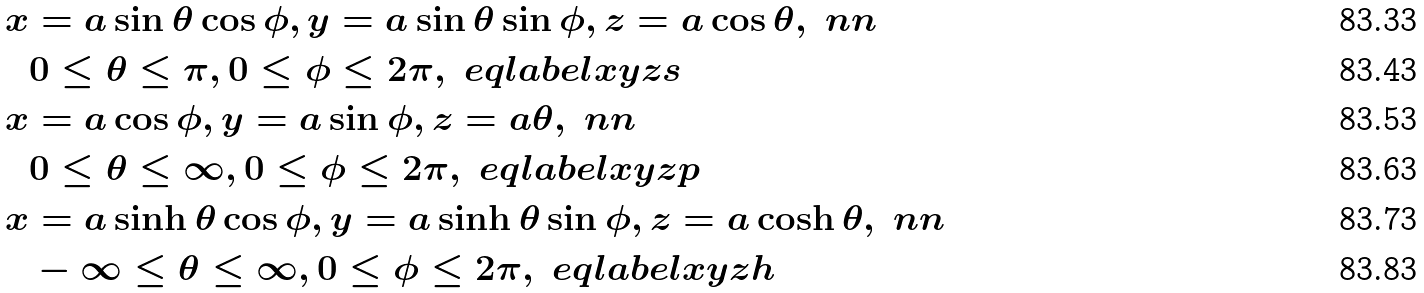<formula> <loc_0><loc_0><loc_500><loc_500>x & = a \sin \theta \cos \phi , y = a \sin \theta \sin \phi , z = a \cos \theta , \ n n \\ & 0 \leq \theta \leq \pi , 0 \leq \phi \leq 2 \pi , \ e q l a b e l { x y z s } \\ x & = a \cos \phi , y = a \sin \phi , z = a \theta , \ n n \\ & 0 \leq \theta \leq \infty , 0 \leq \phi \leq 2 \pi , \ e q l a b e l { x y z p } \\ x & = a \sinh \theta \cos \phi , y = a \sinh \theta \sin \phi , z = a \cosh \theta , \ n n \\ & - \infty \leq \theta \leq \infty , 0 \leq \phi \leq 2 \pi , \ e q l a b e l { x y z h }</formula> 